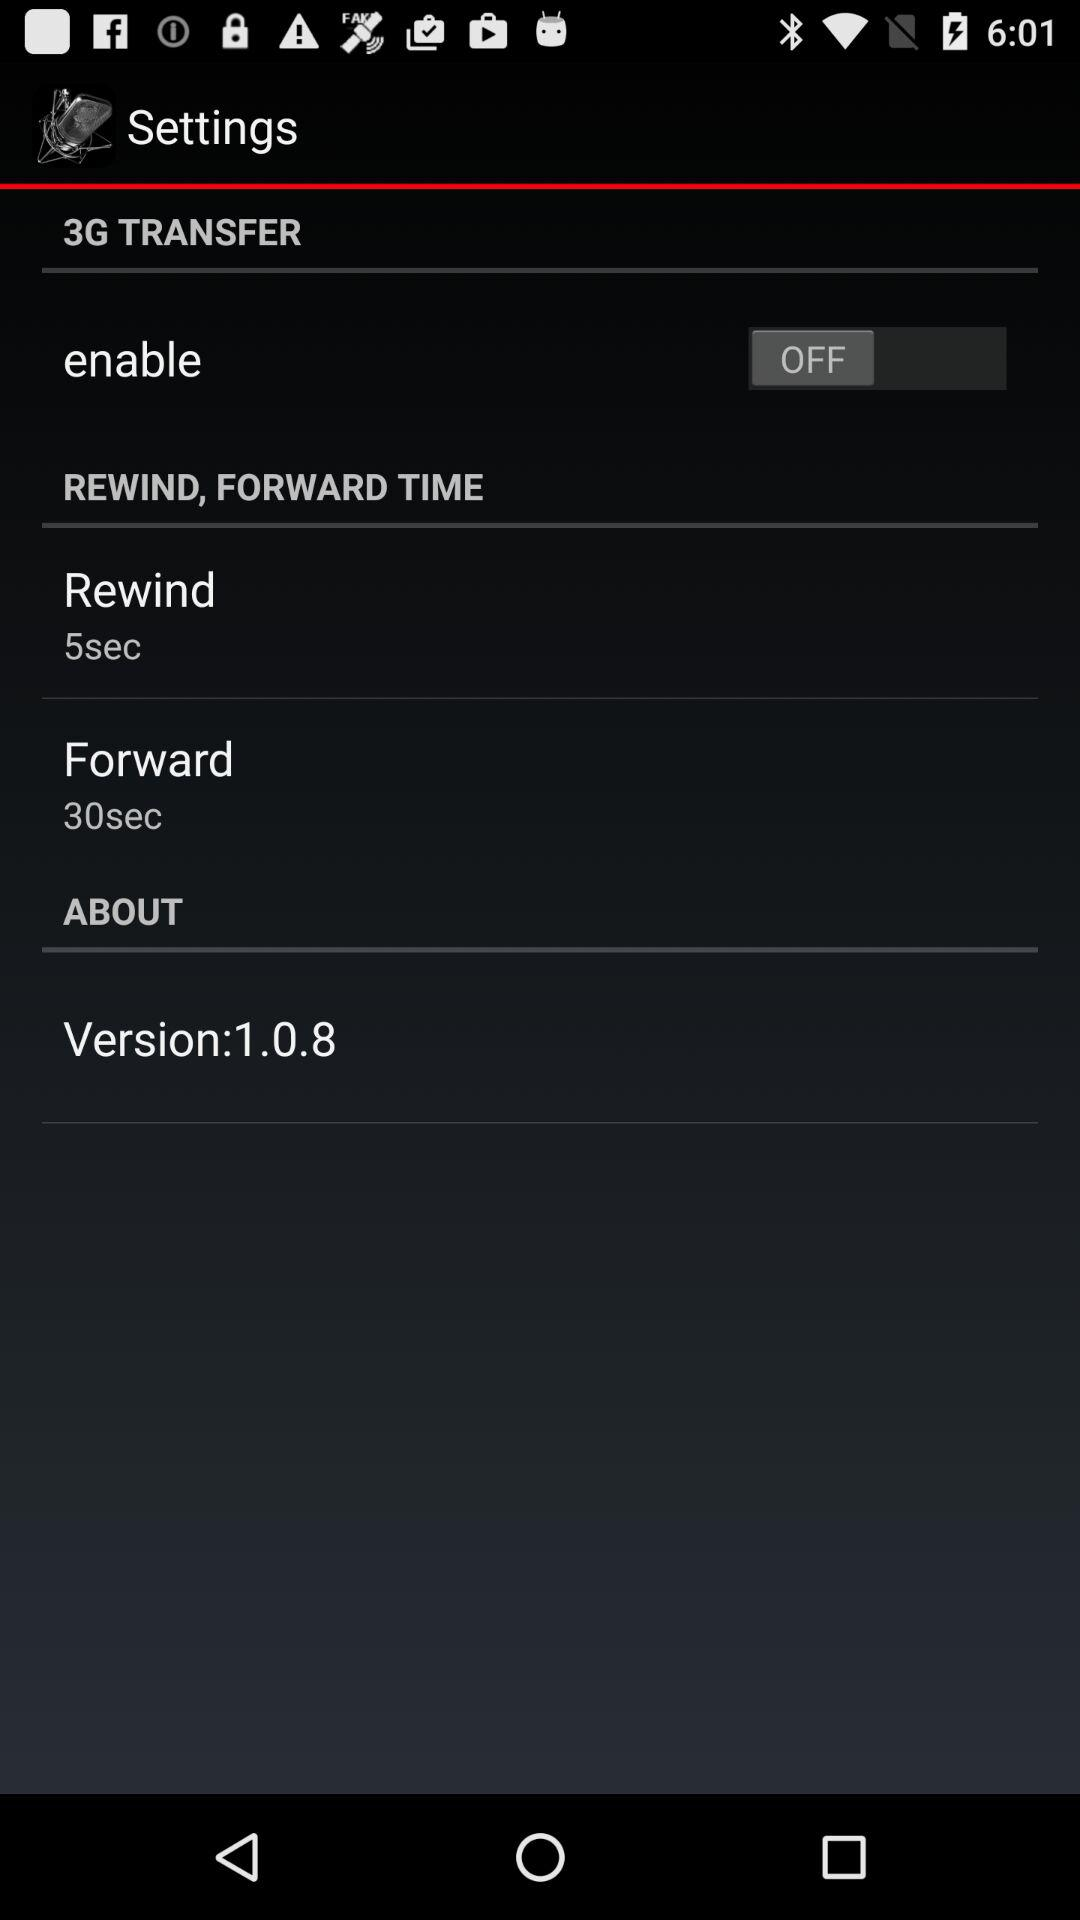What is the status of the "enable"? The status is "off". 